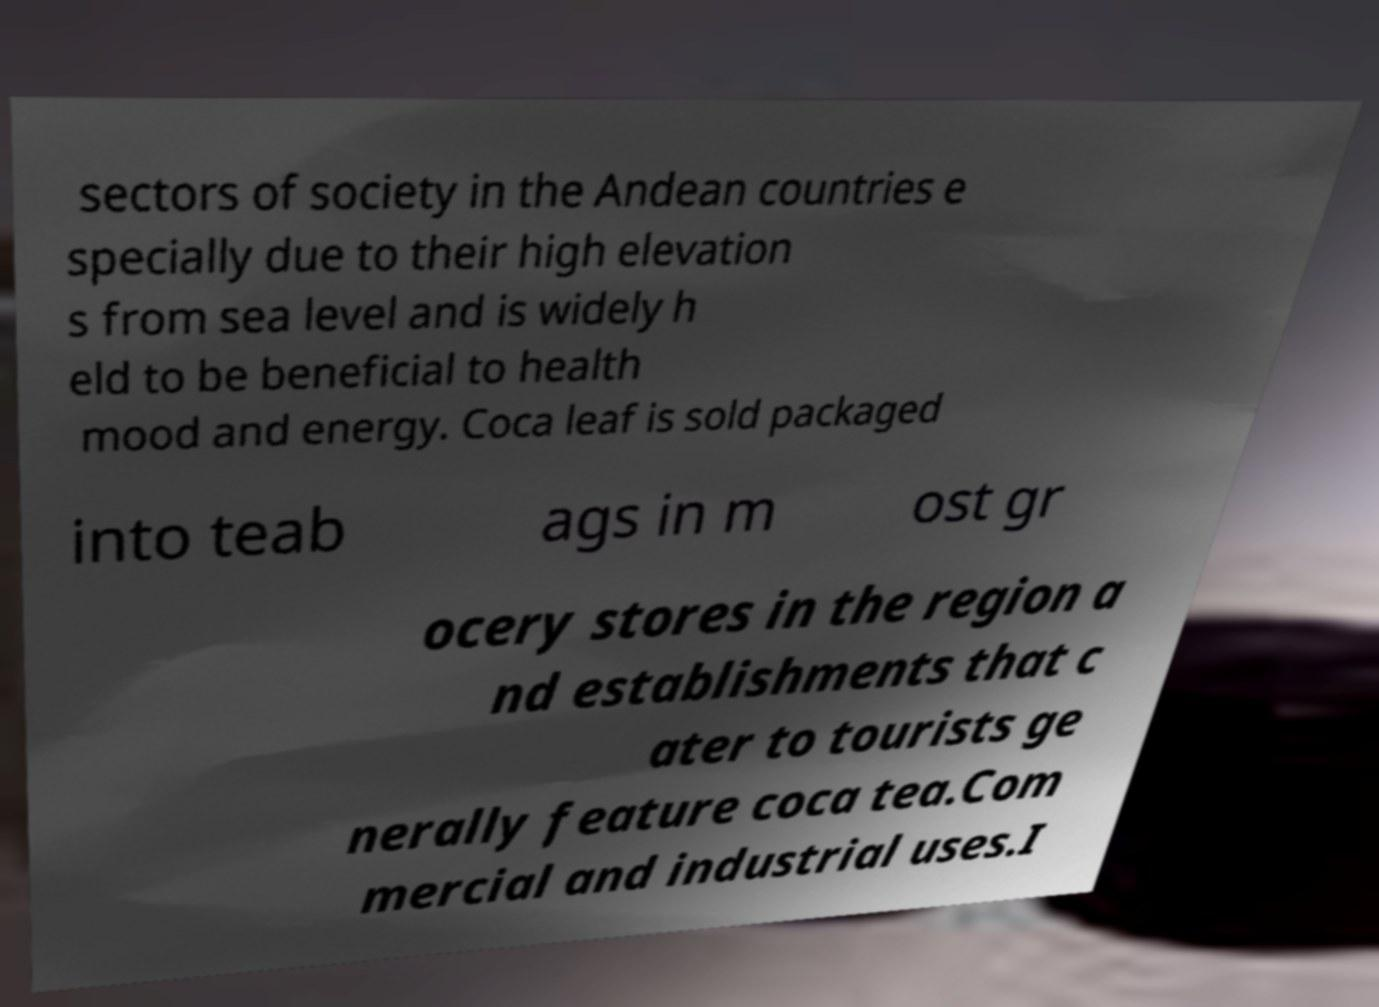What messages or text are displayed in this image? I need them in a readable, typed format. sectors of society in the Andean countries e specially due to their high elevation s from sea level and is widely h eld to be beneficial to health mood and energy. Coca leaf is sold packaged into teab ags in m ost gr ocery stores in the region a nd establishments that c ater to tourists ge nerally feature coca tea.Com mercial and industrial uses.I 